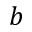Convert formula to latex. <formula><loc_0><loc_0><loc_500><loc_500>b</formula> 